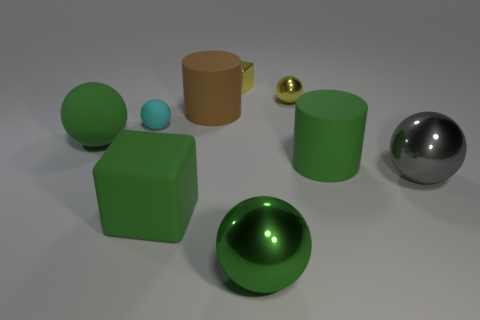Which object in this image appears to be the most reflective? The object with the highest reflectivity in the image is the large sphere on the right side. Its surface acts like a mirror, reflecting the environment with great clarity compared to the other objects present. 